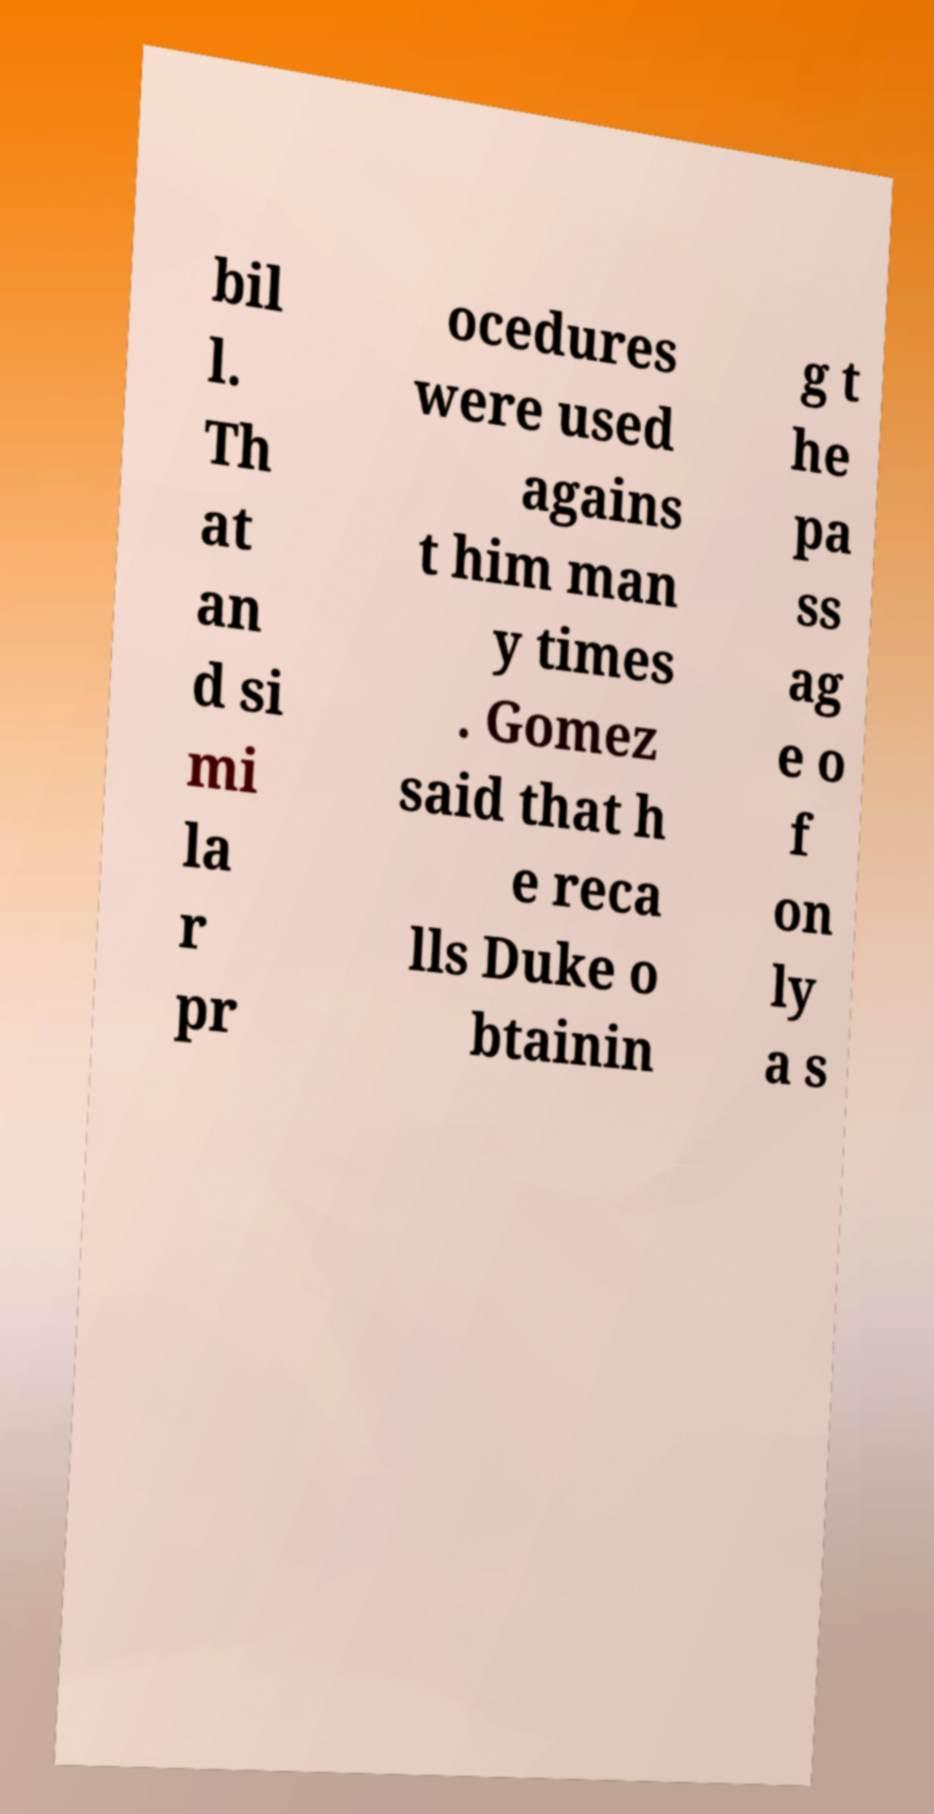What messages or text are displayed in this image? I need them in a readable, typed format. bil l. Th at an d si mi la r pr ocedures were used agains t him man y times . Gomez said that h e reca lls Duke o btainin g t he pa ss ag e o f on ly a s 